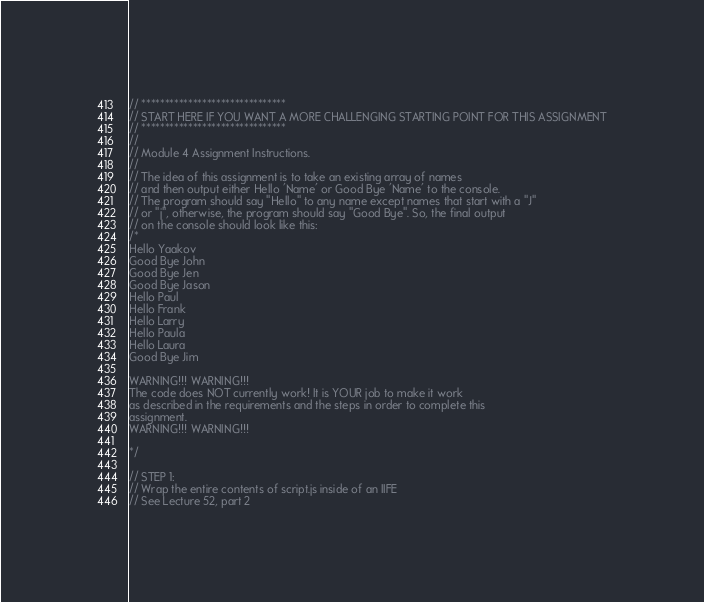<code> <loc_0><loc_0><loc_500><loc_500><_JavaScript_>// *******************************
// START HERE IF YOU WANT A MORE CHALLENGING STARTING POINT FOR THIS ASSIGNMENT
// *******************************
//
// Module 4 Assignment Instructions.
//
// The idea of this assignment is to take an existing array of names
// and then output either Hello 'Name' or Good Bye 'Name' to the console.
// The program should say "Hello" to any name except names that start with a "J"
// or "j", otherwise, the program should say "Good Bye". So, the final output
// on the console should look like this:
/*
Hello Yaakov
Good Bye John
Good Bye Jen
Good Bye Jason
Hello Paul
Hello Frank
Hello Larry
Hello Paula
Hello Laura
Good Bye Jim

WARNING!!! WARNING!!!
The code does NOT currently work! It is YOUR job to make it work
as described in the requirements and the steps in order to complete this
assignment.
WARNING!!! WARNING!!!

*/

// STEP 1:
// Wrap the entire contents of script.js inside of an IIFE
// See Lecture 52, part 2</code> 